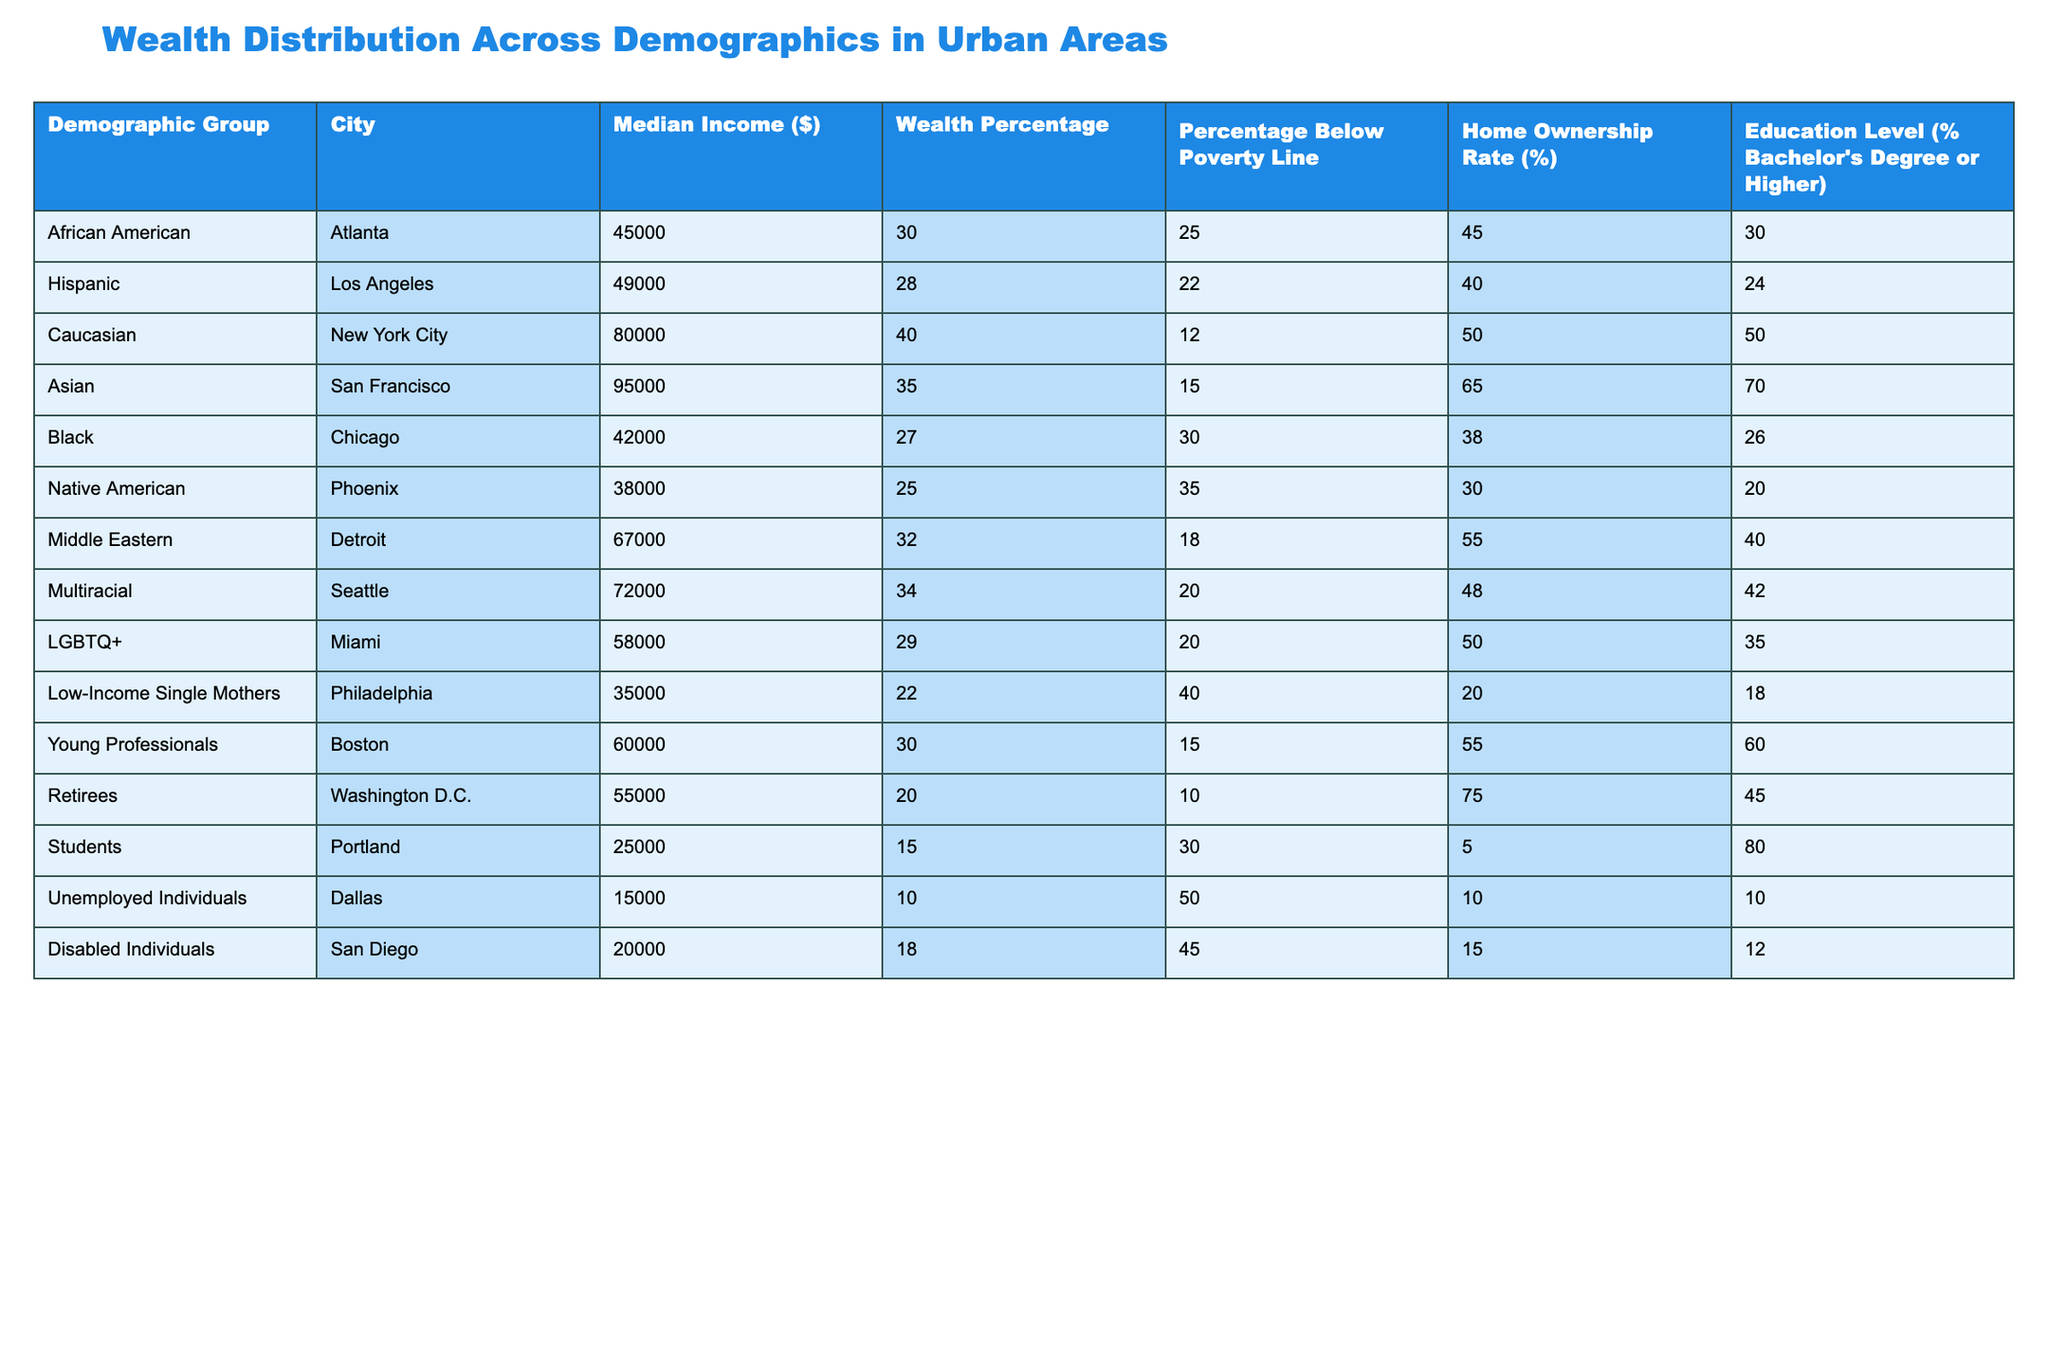What is the median income of the Asian demographic group in San Francisco? The table indicates that the median income for the Asian demographic group in San Francisco is specifically listed in the corresponding row. Looking directly at the data, it states 95000.
Answer: 95000 What percentage of the population is below the poverty line for Low-Income Single Mothers in Philadelphia? The table lists the percentage below the poverty line for Low-Income Single Mothers and provides a direct value. According to the data, it is 40.
Answer: 40 Which demographic has the highest home ownership rate, and what is that percentage? By scanning the home ownership rates across the different demographics, we need to identify which one has the highest value. In the table, we see that Retirees in Washington D.C. have a home ownership rate of 75, which is the highest.
Answer: 75 Which two demographic groups have a median income below $50,000? To find the demographic groups below $50,000, we filter the table for median incomes less than 50,000. The groups that qualify are Low-Income Single Mothers in Philadelphia (35000) and Unemployed Individuals in Dallas (15000).
Answer: Low-Income Single Mothers, Unemployed Individuals Is the percentage of Bachelor's Degree holders higher among Asian individuals in San Francisco than among Black individuals in Chicago? First, we need to compare the percentage of Bachelor's Degree holders from both groups. The table shows that Asians have a percentage of 70, while Blacks have a percentage of 26. Since 70 is greater than 26, we can conclude that the statement is true.
Answer: Yes What is the average median income of all demographic groups listed in the table? To find the average median income, we first sum all the median incomes: 45000 + 49000 + 80000 + 95000 + 42000 + 38000 + 67000 + 72000 + 58000 + 35000 + 60000 + 55000 + 25000 + 15000 + 20000 = 588000. Then, we divide by the number of groups, which is 15, resulting in an average of 39200.
Answer: 39200 Are more than half of the Asian individuals in San Francisco homeowners? The home ownership rate for Asians in San Francisco is provided in the table as 65. To determine if this is more than half, we check if 65 is greater than 50. Since it is, the statement is true.
Answer: Yes Which demographic groups have a wealth percentage of over 30%? To answer this question, we look for groups that have a wealth percentage greater than 30. From the table, we find that Caucasian (40), Asian (35), Middle Eastern (32), and Multiracial (34) meet this criterion.
Answer: Caucasian, Asian, Middle Eastern, Multiracial How much lower is the median income of the Native American group compared to the median income of the Asian group? The median income for the Native American group is 38000 and for the Asian group, it is 95000. To find the difference, we subtract: 95000 - 38000 = 57000. This means the Native American group's median income is 57000 less than that of the Asian group.
Answer: 57000 